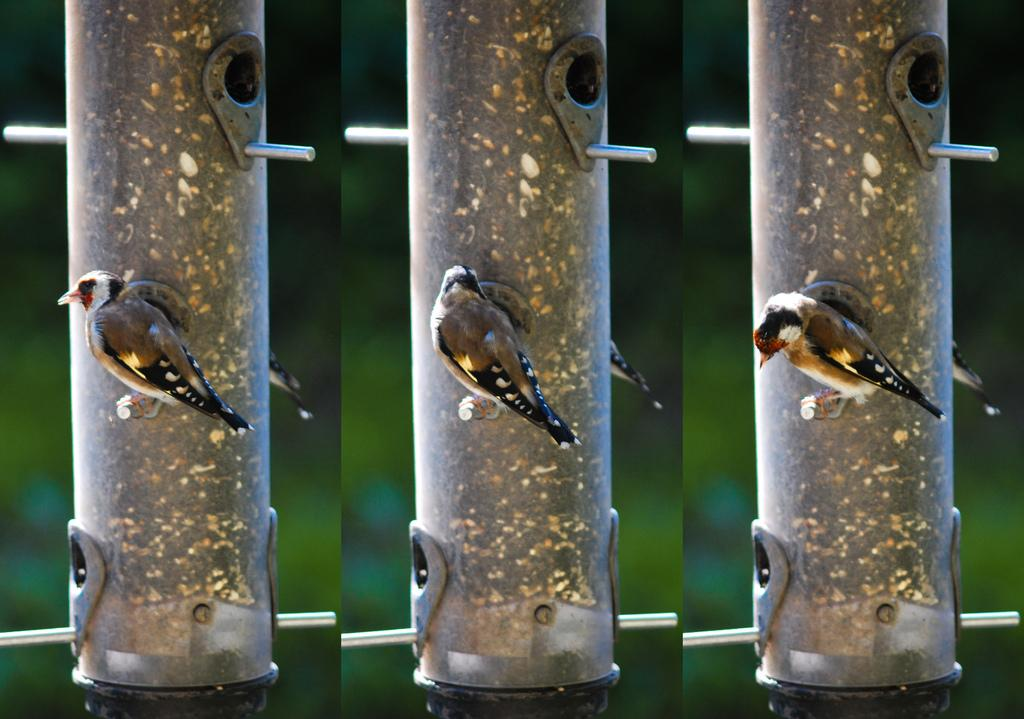How many pictures are included in the collage? The collage consists of three pictures. What is a common element in each of the pictures? Each picture contains a pole. What can be seen on top of the poles in the images? A bird is visible on each pole, but in different angles. What type of oatmeal is being prepared in the image? There is no oatmeal present in the image; it consists of three pictures of poles with birds on top. 